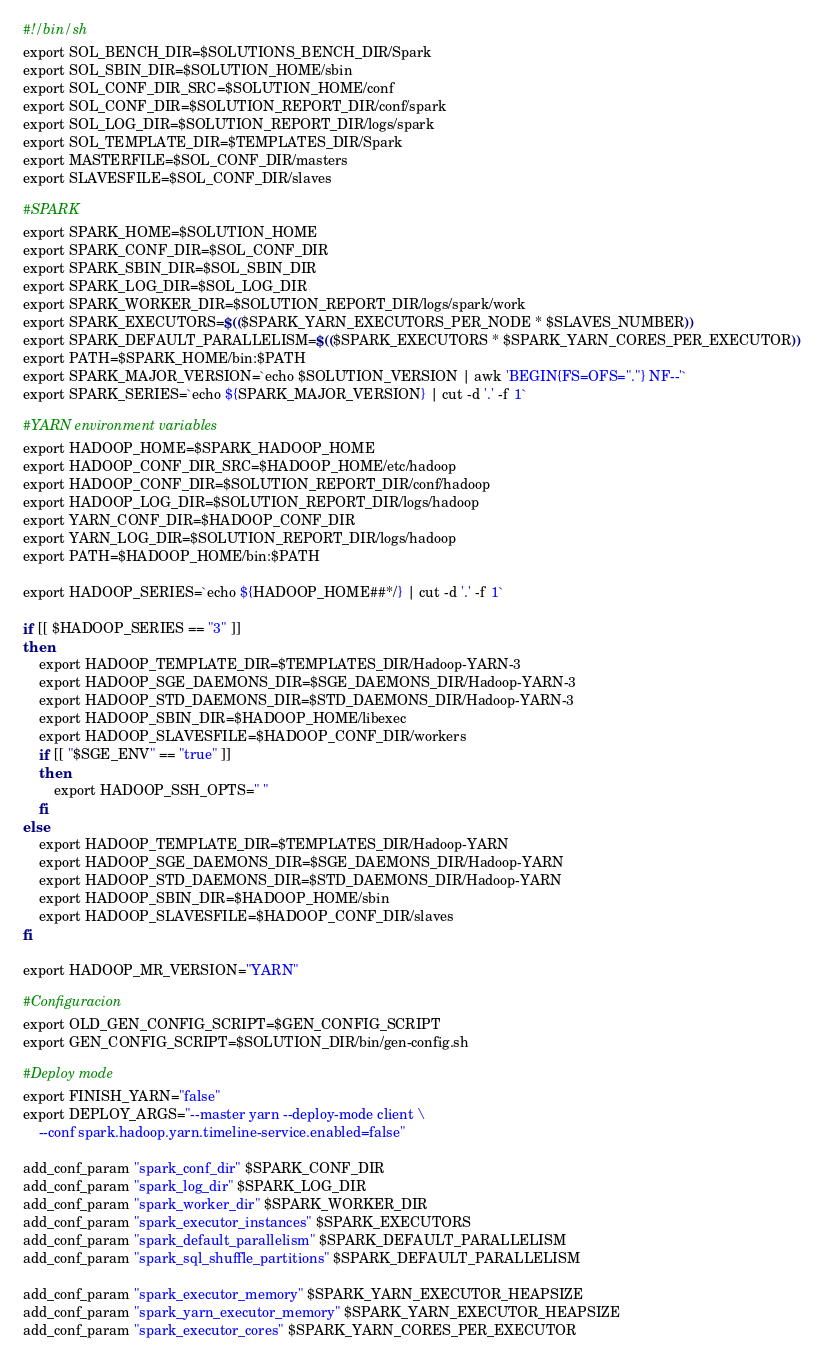Convert code to text. <code><loc_0><loc_0><loc_500><loc_500><_Bash_>#!/bin/sh
export SOL_BENCH_DIR=$SOLUTIONS_BENCH_DIR/Spark
export SOL_SBIN_DIR=$SOLUTION_HOME/sbin
export SOL_CONF_DIR_SRC=$SOLUTION_HOME/conf
export SOL_CONF_DIR=$SOLUTION_REPORT_DIR/conf/spark
export SOL_LOG_DIR=$SOLUTION_REPORT_DIR/logs/spark
export SOL_TEMPLATE_DIR=$TEMPLATES_DIR/Spark
export MASTERFILE=$SOL_CONF_DIR/masters
export SLAVESFILE=$SOL_CONF_DIR/slaves

#SPARK
export SPARK_HOME=$SOLUTION_HOME
export SPARK_CONF_DIR=$SOL_CONF_DIR
export SPARK_SBIN_DIR=$SOL_SBIN_DIR
export SPARK_LOG_DIR=$SOL_LOG_DIR
export SPARK_WORKER_DIR=$SOLUTION_REPORT_DIR/logs/spark/work
export SPARK_EXECUTORS=$(($SPARK_YARN_EXECUTORS_PER_NODE * $SLAVES_NUMBER))
export SPARK_DEFAULT_PARALLELISM=$(($SPARK_EXECUTORS * $SPARK_YARN_CORES_PER_EXECUTOR))
export PATH=$SPARK_HOME/bin:$PATH
export SPARK_MAJOR_VERSION=`echo $SOLUTION_VERSION | awk 'BEGIN{FS=OFS="."} NF--'`
export SPARK_SERIES=`echo ${SPARK_MAJOR_VERSION} | cut -d '.' -f 1`

#YARN environment variables
export HADOOP_HOME=$SPARK_HADOOP_HOME
export HADOOP_CONF_DIR_SRC=$HADOOP_HOME/etc/hadoop
export HADOOP_CONF_DIR=$SOLUTION_REPORT_DIR/conf/hadoop
export HADOOP_LOG_DIR=$SOLUTION_REPORT_DIR/logs/hadoop
export YARN_CONF_DIR=$HADOOP_CONF_DIR
export YARN_LOG_DIR=$SOLUTION_REPORT_DIR/logs/hadoop
export PATH=$HADOOP_HOME/bin:$PATH

export HADOOP_SERIES=`echo ${HADOOP_HOME##*/} | cut -d '.' -f 1`

if [[ $HADOOP_SERIES == "3" ]]
then
	export HADOOP_TEMPLATE_DIR=$TEMPLATES_DIR/Hadoop-YARN-3
	export HADOOP_SGE_DAEMONS_DIR=$SGE_DAEMONS_DIR/Hadoop-YARN-3
	export HADOOP_STD_DAEMONS_DIR=$STD_DAEMONS_DIR/Hadoop-YARN-3
	export HADOOP_SBIN_DIR=$HADOOP_HOME/libexec
	export HADOOP_SLAVESFILE=$HADOOP_CONF_DIR/workers
	if [[ "$SGE_ENV" == "true" ]]
	then
		export HADOOP_SSH_OPTS=" "
	fi
else
	export HADOOP_TEMPLATE_DIR=$TEMPLATES_DIR/Hadoop-YARN
	export HADOOP_SGE_DAEMONS_DIR=$SGE_DAEMONS_DIR/Hadoop-YARN
	export HADOOP_STD_DAEMONS_DIR=$STD_DAEMONS_DIR/Hadoop-YARN
	export HADOOP_SBIN_DIR=$HADOOP_HOME/sbin
	export HADOOP_SLAVESFILE=$HADOOP_CONF_DIR/slaves
fi

export HADOOP_MR_VERSION="YARN"

#Configuracion
export OLD_GEN_CONFIG_SCRIPT=$GEN_CONFIG_SCRIPT
export GEN_CONFIG_SCRIPT=$SOLUTION_DIR/bin/gen-config.sh

#Deploy mode
export FINISH_YARN="false"
export DEPLOY_ARGS="--master yarn --deploy-mode client \
	--conf spark.hadoop.yarn.timeline-service.enabled=false"

add_conf_param "spark_conf_dir" $SPARK_CONF_DIR
add_conf_param "spark_log_dir" $SPARK_LOG_DIR
add_conf_param "spark_worker_dir" $SPARK_WORKER_DIR
add_conf_param "spark_executor_instances" $SPARK_EXECUTORS
add_conf_param "spark_default_parallelism" $SPARK_DEFAULT_PARALLELISM
add_conf_param "spark_sql_shuffle_partitions" $SPARK_DEFAULT_PARALLELISM

add_conf_param "spark_executor_memory" $SPARK_YARN_EXECUTOR_HEAPSIZE
add_conf_param "spark_yarn_executor_memory" $SPARK_YARN_EXECUTOR_HEAPSIZE
add_conf_param "spark_executor_cores" $SPARK_YARN_CORES_PER_EXECUTOR

</code> 